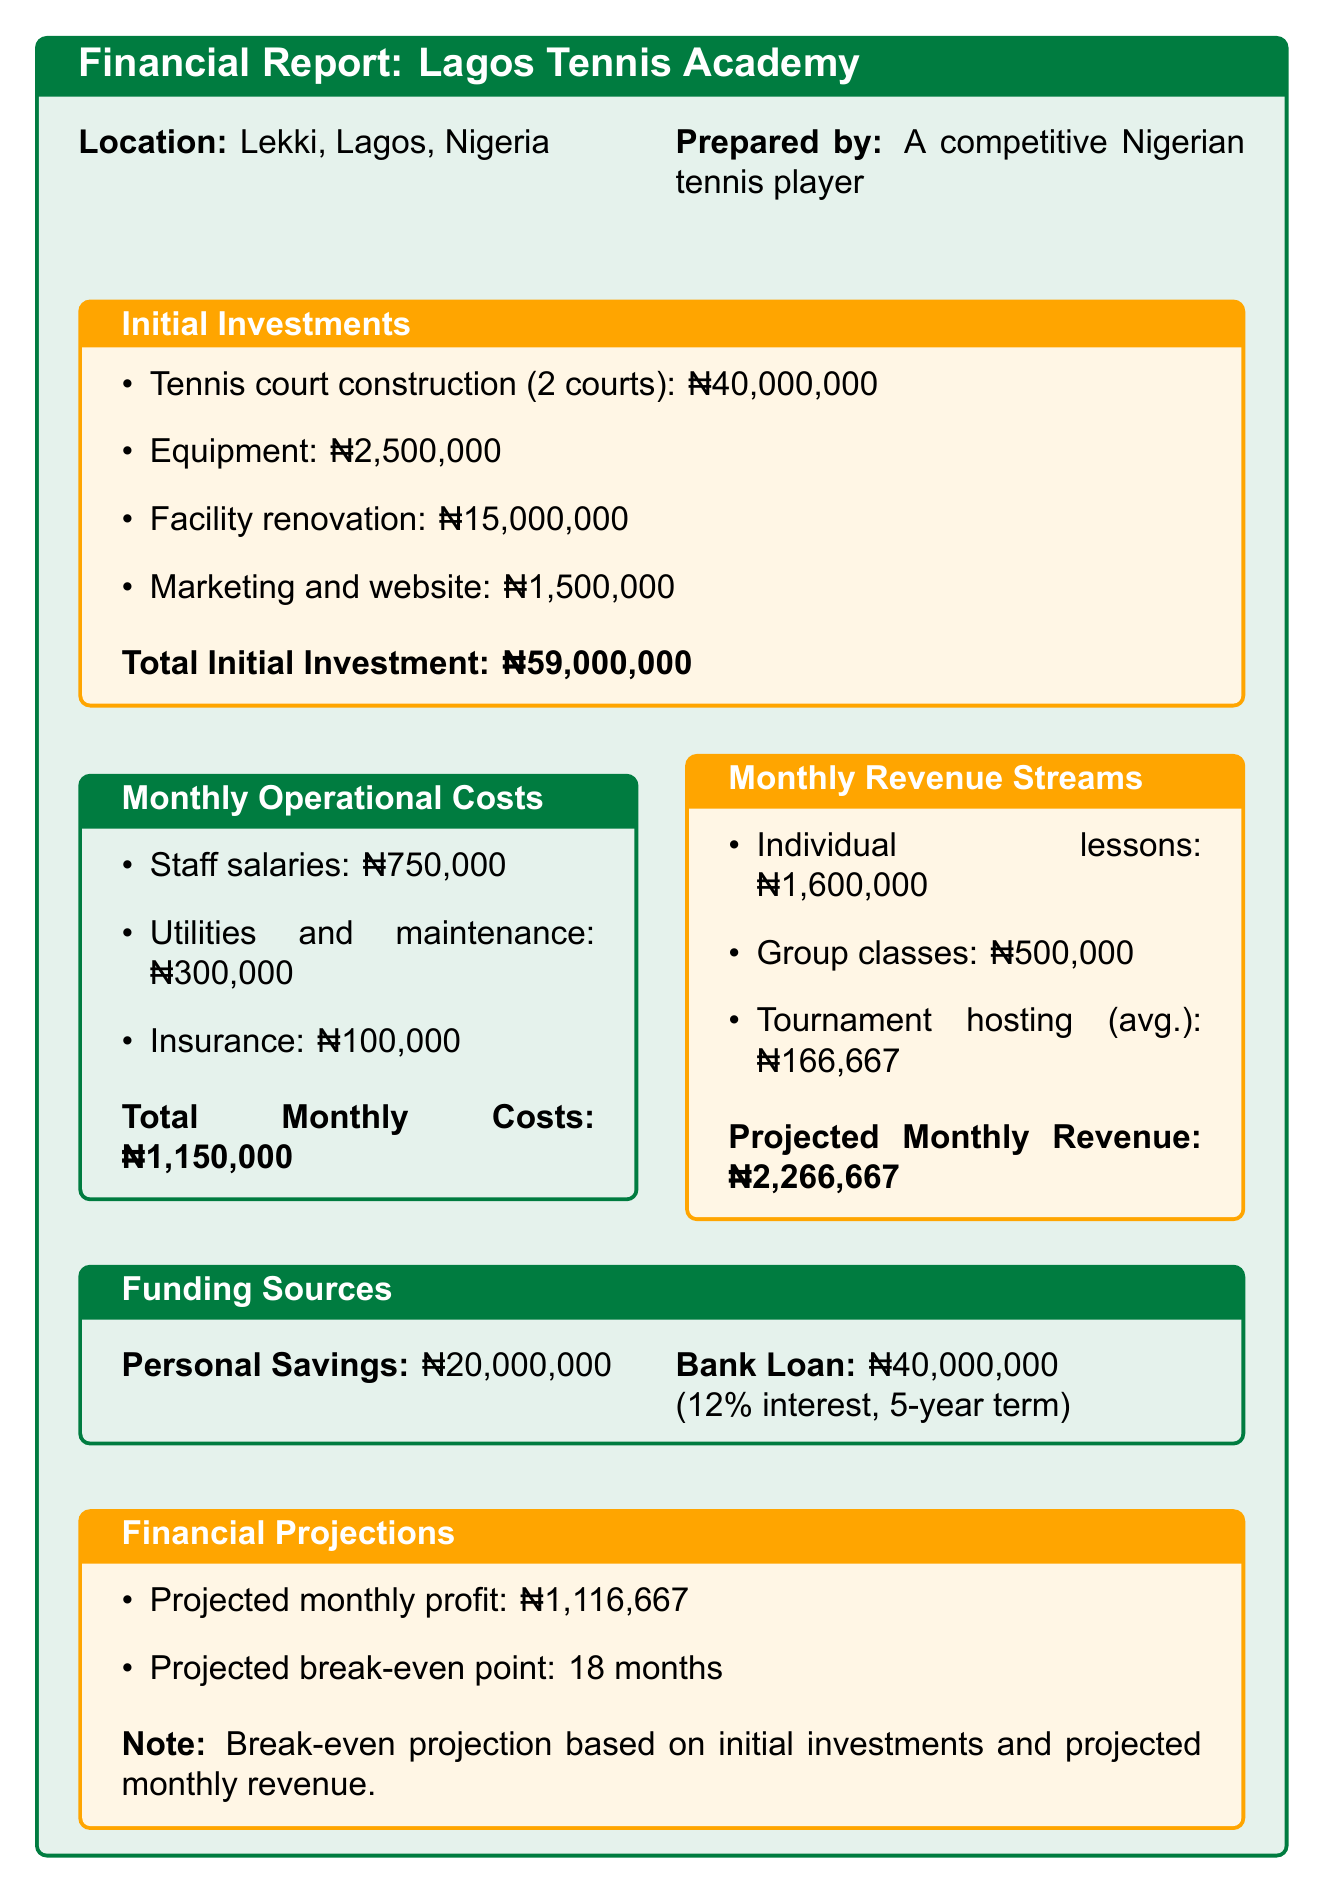what is the total initial investment? The total initial investment is the sum of all initial investment items listed in the document.
Answer: ₦59,000,000 what is the monthly cost for staff salaries? The monthly cost for staff salaries is specifically mentioned in the operational costs section of the document.
Answer: ₦750,000 how many coaching staff are mentioned? The document mentions the number of coaches and administrators in the operational costs section.
Answer: 3 what is the estimated monthly revenue from individual lessons? The estimated monthly revenue from individual lessons is calculated based on the price per hour and estimated monthly hours in the revenue streams section.
Answer: ₦1,600,000 how many months will it take to break even? The break-even period is provided in the financial projections section of the document.
Answer: 18 months what is the location of the Lagos Tennis Academy? The document specifies the location right at the beginning of the financial report section.
Answer: Lekki, Lagos, Nigeria how much is the bank loan amount? The bank loan amount is directly listed under the funding sources section of the document.
Answer: ₦40,000,000 what is the monthly cost for utilities and maintenance? The monthly cost for utilities and maintenance is an itemized expense listed in the operational costs section.
Answer: ₦300,000 how many estimated annual tournament hosting events are there? The number of estimated annual tournament hosting events is specified in the revenue streams section of the document.
Answer: 4 